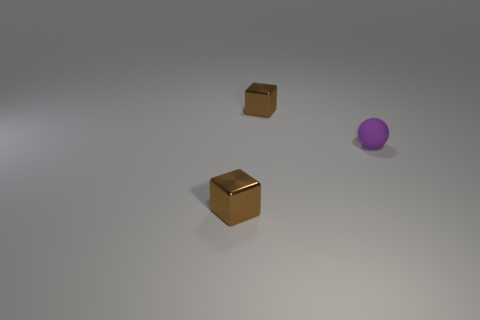Add 1 small green balls. How many objects exist? 4 Subtract all spheres. How many objects are left? 2 Subtract 0 brown balls. How many objects are left? 3 Subtract all tiny blue matte cylinders. Subtract all brown blocks. How many objects are left? 1 Add 1 tiny matte balls. How many tiny matte balls are left? 2 Add 1 tiny metallic blocks. How many tiny metallic blocks exist? 3 